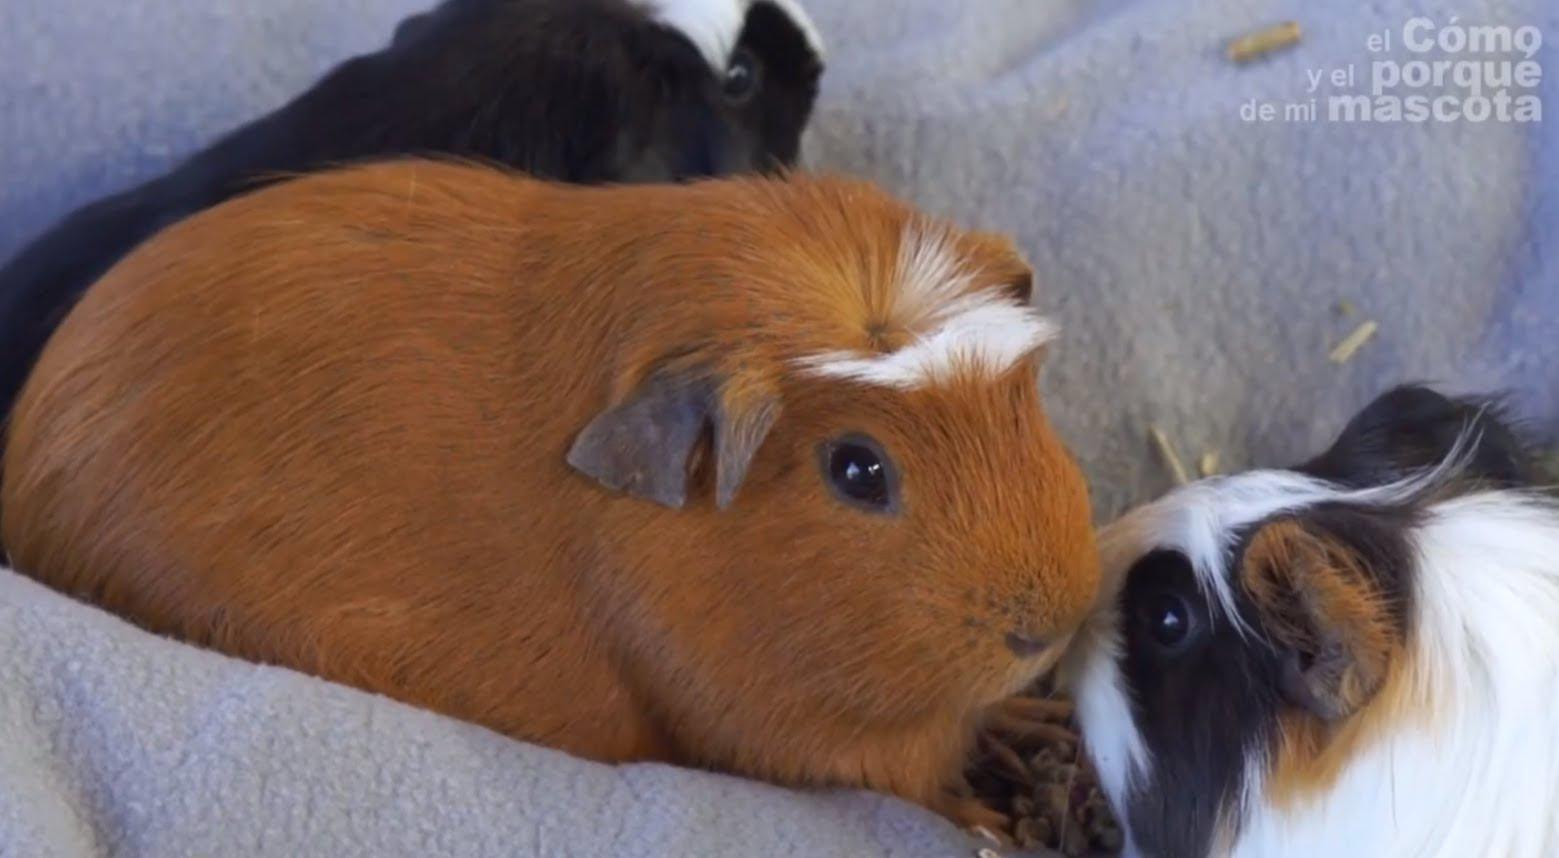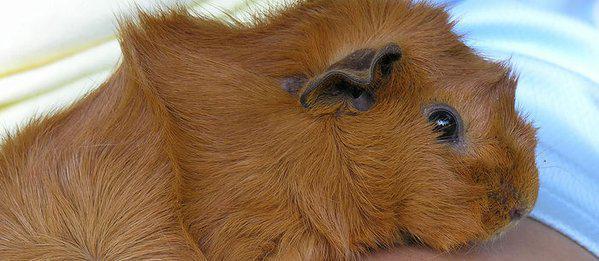The first image is the image on the left, the second image is the image on the right. Analyze the images presented: Is the assertion "A guinea pig with a white snout is facing left." valid? Answer yes or no. No. The first image is the image on the left, the second image is the image on the right. Given the left and right images, does the statement "There are exactly 3 animals." hold true? Answer yes or no. No. 